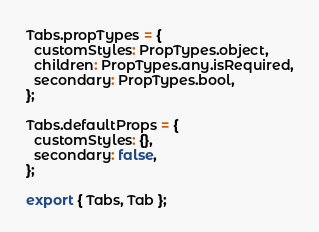<code> <loc_0><loc_0><loc_500><loc_500><_JavaScript_>
Tabs.propTypes = {
  customStyles: PropTypes.object,
  children: PropTypes.any.isRequired,
  secondary: PropTypes.bool,
};

Tabs.defaultProps = {
  customStyles: {},
  secondary: false,
};

export { Tabs, Tab };
</code> 